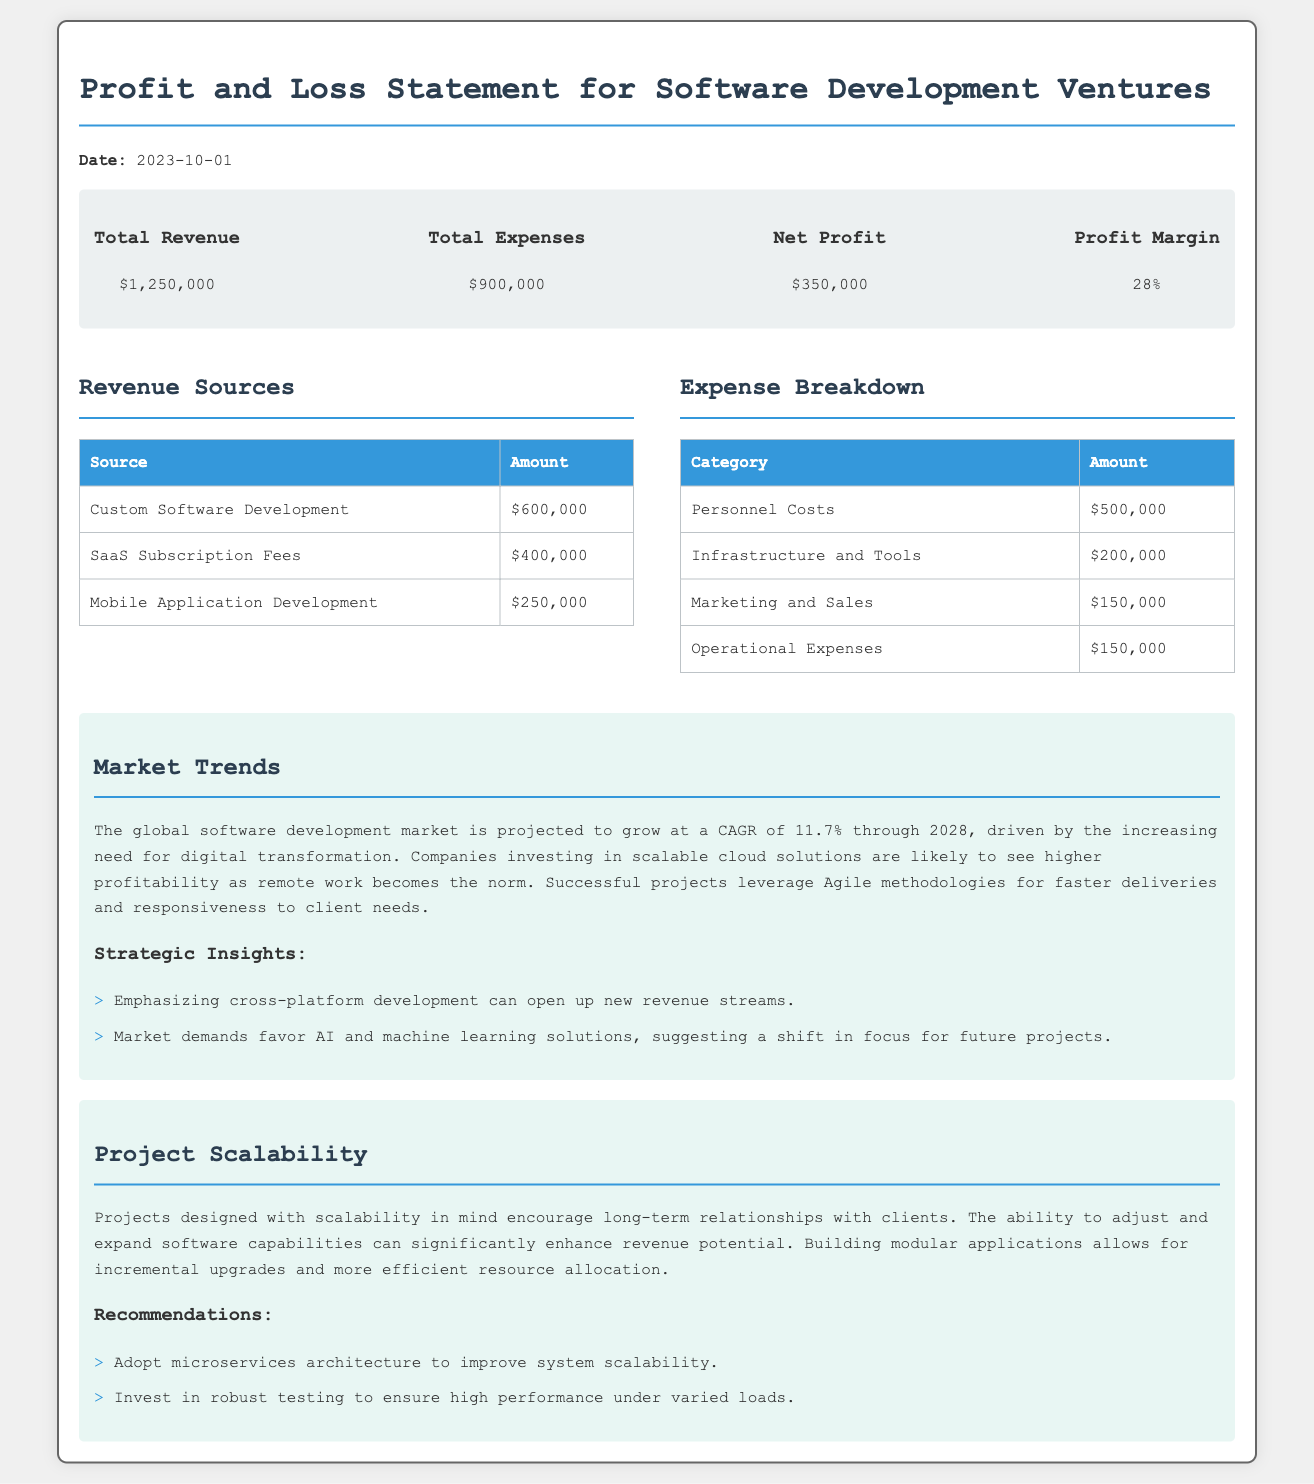What is the total revenue? The total revenue is stated in the summary section of the document as $1,250,000.
Answer: $1,250,000 What are the total expenses? The total expenses are provided in the summary section of the document, which states they are $900,000.
Answer: $900,000 What is the net profit? The net profit is highlighted in the summary section as $350,000.
Answer: $350,000 What is the profit margin? The profit margin is given in the summary section and is calculated as 28%.
Answer: 28% What is the revenue from SaaS subscription fees? The revenue from SaaS subscription fees is specified in the revenue sources table, amounting to $400,000.
Answer: $400,000 What category has the highest expense? The highest expense category is personnel costs, which sum up to $500,000 as detailed in the expenses table.
Answer: Personnel Costs What is the projected CAGR for the software development market? The document states that the global software development market is projected to grow at a CAGR of 11.7%.
Answer: 11.7% What architectural approach is recommended for improving scalability? The recommendations suggest adopting microservices architecture as a means to improve system scalability.
Answer: Microservices architecture What is one strategic insight mentioned in the market trends section? One strategic insight is the emphasis on cross-platform development for new revenue streams as mentioned in the insights list.
Answer: Cross-platform development 